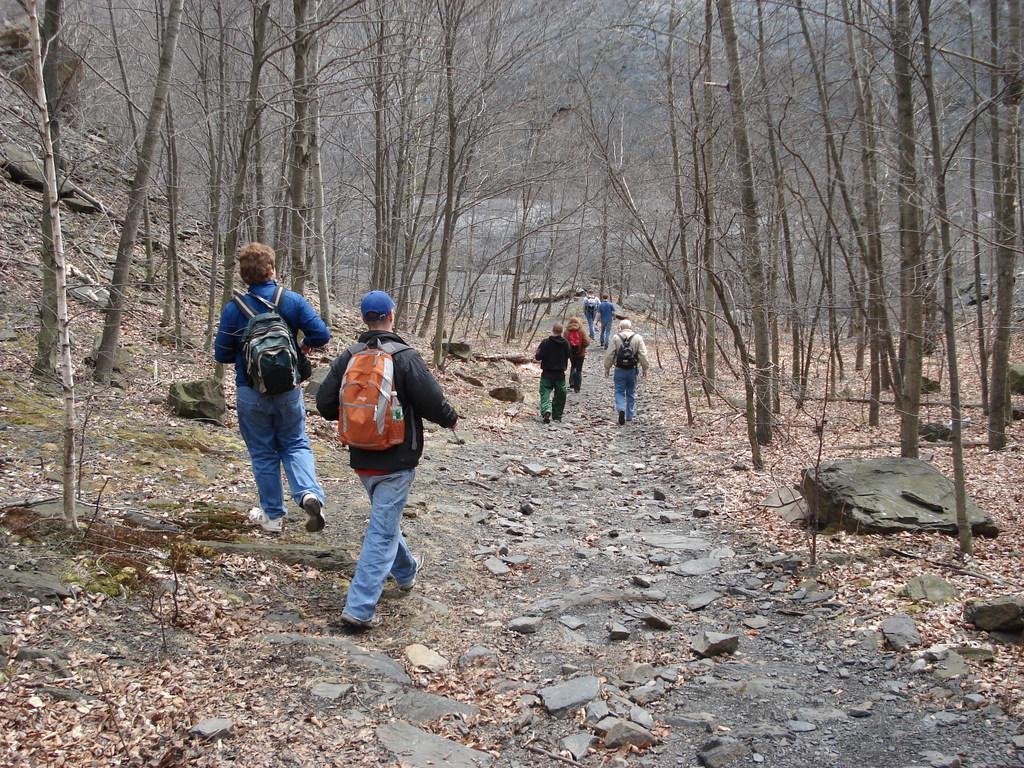How would you summarize this image in a sentence or two? In this picture we can see few people are walking on the ground. There are stones and dried leaves. In the background there are trees. 